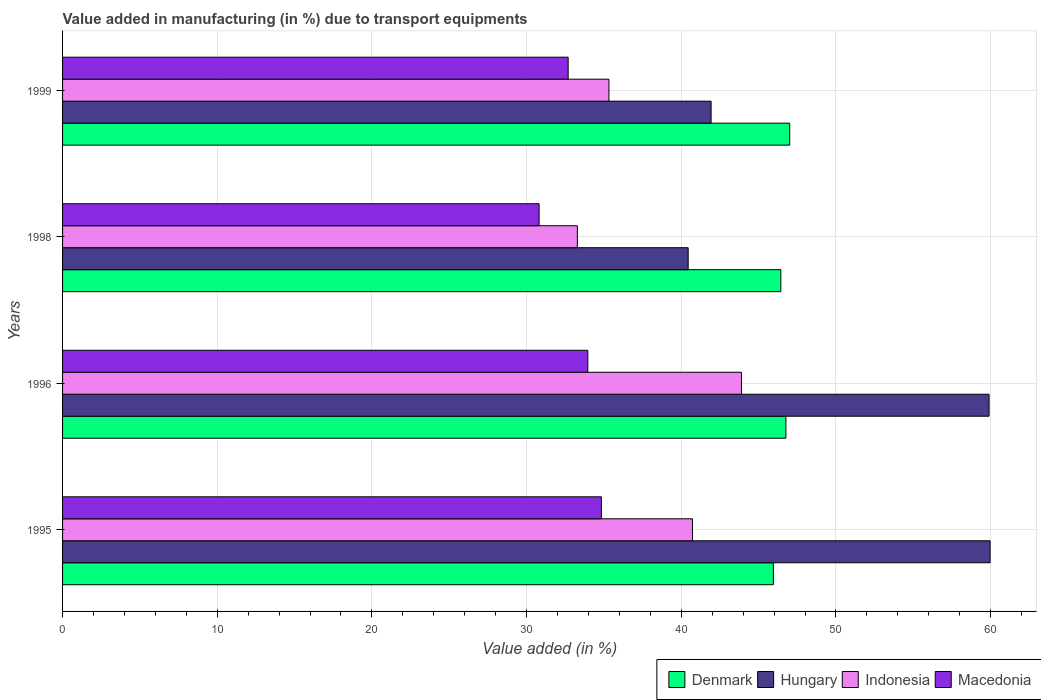Are the number of bars per tick equal to the number of legend labels?
Ensure brevity in your answer.  Yes. How many bars are there on the 1st tick from the top?
Give a very brief answer. 4. What is the label of the 2nd group of bars from the top?
Provide a short and direct response. 1998. What is the percentage of value added in manufacturing due to transport equipments in Macedonia in 1998?
Provide a short and direct response. 30.81. Across all years, what is the maximum percentage of value added in manufacturing due to transport equipments in Denmark?
Your answer should be very brief. 47.01. Across all years, what is the minimum percentage of value added in manufacturing due to transport equipments in Denmark?
Give a very brief answer. 45.95. In which year was the percentage of value added in manufacturing due to transport equipments in Indonesia maximum?
Your answer should be very brief. 1996. In which year was the percentage of value added in manufacturing due to transport equipments in Indonesia minimum?
Your answer should be compact. 1998. What is the total percentage of value added in manufacturing due to transport equipments in Indonesia in the graph?
Make the answer very short. 153.22. What is the difference between the percentage of value added in manufacturing due to transport equipments in Macedonia in 1995 and that in 1999?
Your answer should be compact. 2.15. What is the difference between the percentage of value added in manufacturing due to transport equipments in Indonesia in 1995 and the percentage of value added in manufacturing due to transport equipments in Hungary in 1998?
Your answer should be compact. 0.28. What is the average percentage of value added in manufacturing due to transport equipments in Indonesia per year?
Your response must be concise. 38.3. In the year 1995, what is the difference between the percentage of value added in manufacturing due to transport equipments in Denmark and percentage of value added in manufacturing due to transport equipments in Hungary?
Ensure brevity in your answer.  -14.01. In how many years, is the percentage of value added in manufacturing due to transport equipments in Hungary greater than 8 %?
Provide a short and direct response. 4. What is the ratio of the percentage of value added in manufacturing due to transport equipments in Denmark in 1998 to that in 1999?
Offer a terse response. 0.99. Is the percentage of value added in manufacturing due to transport equipments in Denmark in 1995 less than that in 1996?
Provide a short and direct response. Yes. Is the difference between the percentage of value added in manufacturing due to transport equipments in Denmark in 1996 and 1998 greater than the difference between the percentage of value added in manufacturing due to transport equipments in Hungary in 1996 and 1998?
Give a very brief answer. No. What is the difference between the highest and the second highest percentage of value added in manufacturing due to transport equipments in Denmark?
Your answer should be compact. 0.25. What is the difference between the highest and the lowest percentage of value added in manufacturing due to transport equipments in Denmark?
Your answer should be very brief. 1.06. Is it the case that in every year, the sum of the percentage of value added in manufacturing due to transport equipments in Indonesia and percentage of value added in manufacturing due to transport equipments in Hungary is greater than the sum of percentage of value added in manufacturing due to transport equipments in Denmark and percentage of value added in manufacturing due to transport equipments in Macedonia?
Keep it short and to the point. No. What does the 1st bar from the bottom in 1999 represents?
Provide a short and direct response. Denmark. How many bars are there?
Offer a terse response. 16. What is the difference between two consecutive major ticks on the X-axis?
Your answer should be very brief. 10. Are the values on the major ticks of X-axis written in scientific E-notation?
Your answer should be very brief. No. Does the graph contain any zero values?
Provide a short and direct response. No. Does the graph contain grids?
Offer a terse response. Yes. Where does the legend appear in the graph?
Keep it short and to the point. Bottom right. What is the title of the graph?
Make the answer very short. Value added in manufacturing (in %) due to transport equipments. Does "Tajikistan" appear as one of the legend labels in the graph?
Your answer should be very brief. No. What is the label or title of the X-axis?
Make the answer very short. Value added (in %). What is the Value added (in %) of Denmark in 1995?
Give a very brief answer. 45.95. What is the Value added (in %) of Hungary in 1995?
Keep it short and to the point. 59.97. What is the Value added (in %) in Indonesia in 1995?
Make the answer very short. 40.72. What is the Value added (in %) in Macedonia in 1995?
Offer a very short reply. 34.83. What is the Value added (in %) of Denmark in 1996?
Your answer should be very brief. 46.76. What is the Value added (in %) in Hungary in 1996?
Make the answer very short. 59.9. What is the Value added (in %) in Indonesia in 1996?
Offer a terse response. 43.89. What is the Value added (in %) of Macedonia in 1996?
Your answer should be very brief. 33.96. What is the Value added (in %) in Denmark in 1998?
Give a very brief answer. 46.44. What is the Value added (in %) of Hungary in 1998?
Your answer should be compact. 40.44. What is the Value added (in %) in Indonesia in 1998?
Make the answer very short. 33.28. What is the Value added (in %) of Macedonia in 1998?
Ensure brevity in your answer.  30.81. What is the Value added (in %) in Denmark in 1999?
Keep it short and to the point. 47.01. What is the Value added (in %) of Hungary in 1999?
Ensure brevity in your answer.  41.93. What is the Value added (in %) of Indonesia in 1999?
Your response must be concise. 35.32. What is the Value added (in %) of Macedonia in 1999?
Ensure brevity in your answer.  32.69. Across all years, what is the maximum Value added (in %) in Denmark?
Your answer should be very brief. 47.01. Across all years, what is the maximum Value added (in %) of Hungary?
Offer a very short reply. 59.97. Across all years, what is the maximum Value added (in %) of Indonesia?
Your response must be concise. 43.89. Across all years, what is the maximum Value added (in %) in Macedonia?
Give a very brief answer. 34.83. Across all years, what is the minimum Value added (in %) in Denmark?
Provide a succinct answer. 45.95. Across all years, what is the minimum Value added (in %) in Hungary?
Ensure brevity in your answer.  40.44. Across all years, what is the minimum Value added (in %) in Indonesia?
Ensure brevity in your answer.  33.28. Across all years, what is the minimum Value added (in %) of Macedonia?
Keep it short and to the point. 30.81. What is the total Value added (in %) of Denmark in the graph?
Your answer should be very brief. 186.16. What is the total Value added (in %) in Hungary in the graph?
Provide a succinct answer. 202.24. What is the total Value added (in %) of Indonesia in the graph?
Your response must be concise. 153.22. What is the total Value added (in %) of Macedonia in the graph?
Your answer should be very brief. 132.28. What is the difference between the Value added (in %) of Denmark in 1995 and that in 1996?
Give a very brief answer. -0.81. What is the difference between the Value added (in %) of Hungary in 1995 and that in 1996?
Keep it short and to the point. 0.07. What is the difference between the Value added (in %) of Indonesia in 1995 and that in 1996?
Ensure brevity in your answer.  -3.17. What is the difference between the Value added (in %) in Macedonia in 1995 and that in 1996?
Make the answer very short. 0.88. What is the difference between the Value added (in %) in Denmark in 1995 and that in 1998?
Your answer should be compact. -0.48. What is the difference between the Value added (in %) of Hungary in 1995 and that in 1998?
Make the answer very short. 19.52. What is the difference between the Value added (in %) in Indonesia in 1995 and that in 1998?
Provide a succinct answer. 7.44. What is the difference between the Value added (in %) of Macedonia in 1995 and that in 1998?
Offer a terse response. 4.03. What is the difference between the Value added (in %) of Denmark in 1995 and that in 1999?
Provide a short and direct response. -1.06. What is the difference between the Value added (in %) in Hungary in 1995 and that in 1999?
Provide a short and direct response. 18.04. What is the difference between the Value added (in %) of Indonesia in 1995 and that in 1999?
Offer a very short reply. 5.4. What is the difference between the Value added (in %) of Macedonia in 1995 and that in 1999?
Offer a very short reply. 2.15. What is the difference between the Value added (in %) in Denmark in 1996 and that in 1998?
Your response must be concise. 0.33. What is the difference between the Value added (in %) of Hungary in 1996 and that in 1998?
Give a very brief answer. 19.45. What is the difference between the Value added (in %) in Indonesia in 1996 and that in 1998?
Your answer should be very brief. 10.61. What is the difference between the Value added (in %) in Macedonia in 1996 and that in 1998?
Offer a terse response. 3.15. What is the difference between the Value added (in %) of Denmark in 1996 and that in 1999?
Your response must be concise. -0.25. What is the difference between the Value added (in %) of Hungary in 1996 and that in 1999?
Your response must be concise. 17.97. What is the difference between the Value added (in %) of Indonesia in 1996 and that in 1999?
Give a very brief answer. 8.57. What is the difference between the Value added (in %) of Macedonia in 1996 and that in 1999?
Keep it short and to the point. 1.27. What is the difference between the Value added (in %) in Denmark in 1998 and that in 1999?
Ensure brevity in your answer.  -0.57. What is the difference between the Value added (in %) in Hungary in 1998 and that in 1999?
Offer a very short reply. -1.48. What is the difference between the Value added (in %) of Indonesia in 1998 and that in 1999?
Provide a short and direct response. -2.04. What is the difference between the Value added (in %) of Macedonia in 1998 and that in 1999?
Provide a succinct answer. -1.88. What is the difference between the Value added (in %) in Denmark in 1995 and the Value added (in %) in Hungary in 1996?
Offer a very short reply. -13.94. What is the difference between the Value added (in %) of Denmark in 1995 and the Value added (in %) of Indonesia in 1996?
Your response must be concise. 2.06. What is the difference between the Value added (in %) of Denmark in 1995 and the Value added (in %) of Macedonia in 1996?
Offer a terse response. 12. What is the difference between the Value added (in %) of Hungary in 1995 and the Value added (in %) of Indonesia in 1996?
Make the answer very short. 16.07. What is the difference between the Value added (in %) in Hungary in 1995 and the Value added (in %) in Macedonia in 1996?
Offer a terse response. 26.01. What is the difference between the Value added (in %) of Indonesia in 1995 and the Value added (in %) of Macedonia in 1996?
Give a very brief answer. 6.77. What is the difference between the Value added (in %) in Denmark in 1995 and the Value added (in %) in Hungary in 1998?
Offer a very short reply. 5.51. What is the difference between the Value added (in %) in Denmark in 1995 and the Value added (in %) in Indonesia in 1998?
Offer a terse response. 12.67. What is the difference between the Value added (in %) of Denmark in 1995 and the Value added (in %) of Macedonia in 1998?
Make the answer very short. 15.14. What is the difference between the Value added (in %) of Hungary in 1995 and the Value added (in %) of Indonesia in 1998?
Offer a terse response. 26.68. What is the difference between the Value added (in %) of Hungary in 1995 and the Value added (in %) of Macedonia in 1998?
Offer a very short reply. 29.16. What is the difference between the Value added (in %) in Indonesia in 1995 and the Value added (in %) in Macedonia in 1998?
Your answer should be compact. 9.92. What is the difference between the Value added (in %) in Denmark in 1995 and the Value added (in %) in Hungary in 1999?
Provide a short and direct response. 4.02. What is the difference between the Value added (in %) of Denmark in 1995 and the Value added (in %) of Indonesia in 1999?
Your answer should be very brief. 10.63. What is the difference between the Value added (in %) in Denmark in 1995 and the Value added (in %) in Macedonia in 1999?
Ensure brevity in your answer.  13.27. What is the difference between the Value added (in %) of Hungary in 1995 and the Value added (in %) of Indonesia in 1999?
Offer a very short reply. 24.64. What is the difference between the Value added (in %) in Hungary in 1995 and the Value added (in %) in Macedonia in 1999?
Offer a very short reply. 27.28. What is the difference between the Value added (in %) of Indonesia in 1995 and the Value added (in %) of Macedonia in 1999?
Offer a very short reply. 8.04. What is the difference between the Value added (in %) of Denmark in 1996 and the Value added (in %) of Hungary in 1998?
Ensure brevity in your answer.  6.32. What is the difference between the Value added (in %) in Denmark in 1996 and the Value added (in %) in Indonesia in 1998?
Your answer should be compact. 13.48. What is the difference between the Value added (in %) in Denmark in 1996 and the Value added (in %) in Macedonia in 1998?
Ensure brevity in your answer.  15.96. What is the difference between the Value added (in %) of Hungary in 1996 and the Value added (in %) of Indonesia in 1998?
Your answer should be compact. 26.62. What is the difference between the Value added (in %) of Hungary in 1996 and the Value added (in %) of Macedonia in 1998?
Your answer should be compact. 29.09. What is the difference between the Value added (in %) in Indonesia in 1996 and the Value added (in %) in Macedonia in 1998?
Provide a short and direct response. 13.08. What is the difference between the Value added (in %) of Denmark in 1996 and the Value added (in %) of Hungary in 1999?
Make the answer very short. 4.84. What is the difference between the Value added (in %) in Denmark in 1996 and the Value added (in %) in Indonesia in 1999?
Ensure brevity in your answer.  11.44. What is the difference between the Value added (in %) of Denmark in 1996 and the Value added (in %) of Macedonia in 1999?
Give a very brief answer. 14.08. What is the difference between the Value added (in %) of Hungary in 1996 and the Value added (in %) of Indonesia in 1999?
Offer a terse response. 24.58. What is the difference between the Value added (in %) in Hungary in 1996 and the Value added (in %) in Macedonia in 1999?
Make the answer very short. 27.21. What is the difference between the Value added (in %) in Indonesia in 1996 and the Value added (in %) in Macedonia in 1999?
Keep it short and to the point. 11.21. What is the difference between the Value added (in %) of Denmark in 1998 and the Value added (in %) of Hungary in 1999?
Offer a very short reply. 4.51. What is the difference between the Value added (in %) of Denmark in 1998 and the Value added (in %) of Indonesia in 1999?
Your answer should be compact. 11.11. What is the difference between the Value added (in %) of Denmark in 1998 and the Value added (in %) of Macedonia in 1999?
Offer a terse response. 13.75. What is the difference between the Value added (in %) in Hungary in 1998 and the Value added (in %) in Indonesia in 1999?
Give a very brief answer. 5.12. What is the difference between the Value added (in %) in Hungary in 1998 and the Value added (in %) in Macedonia in 1999?
Your response must be concise. 7.76. What is the difference between the Value added (in %) of Indonesia in 1998 and the Value added (in %) of Macedonia in 1999?
Offer a very short reply. 0.59. What is the average Value added (in %) of Denmark per year?
Your answer should be compact. 46.54. What is the average Value added (in %) in Hungary per year?
Provide a short and direct response. 50.56. What is the average Value added (in %) of Indonesia per year?
Offer a terse response. 38.3. What is the average Value added (in %) in Macedonia per year?
Keep it short and to the point. 33.07. In the year 1995, what is the difference between the Value added (in %) in Denmark and Value added (in %) in Hungary?
Keep it short and to the point. -14.01. In the year 1995, what is the difference between the Value added (in %) in Denmark and Value added (in %) in Indonesia?
Make the answer very short. 5.23. In the year 1995, what is the difference between the Value added (in %) in Denmark and Value added (in %) in Macedonia?
Make the answer very short. 11.12. In the year 1995, what is the difference between the Value added (in %) in Hungary and Value added (in %) in Indonesia?
Your answer should be very brief. 19.24. In the year 1995, what is the difference between the Value added (in %) of Hungary and Value added (in %) of Macedonia?
Your answer should be very brief. 25.13. In the year 1995, what is the difference between the Value added (in %) of Indonesia and Value added (in %) of Macedonia?
Keep it short and to the point. 5.89. In the year 1996, what is the difference between the Value added (in %) of Denmark and Value added (in %) of Hungary?
Ensure brevity in your answer.  -13.13. In the year 1996, what is the difference between the Value added (in %) in Denmark and Value added (in %) in Indonesia?
Offer a terse response. 2.87. In the year 1996, what is the difference between the Value added (in %) of Denmark and Value added (in %) of Macedonia?
Provide a succinct answer. 12.81. In the year 1996, what is the difference between the Value added (in %) in Hungary and Value added (in %) in Indonesia?
Your answer should be compact. 16.01. In the year 1996, what is the difference between the Value added (in %) in Hungary and Value added (in %) in Macedonia?
Make the answer very short. 25.94. In the year 1996, what is the difference between the Value added (in %) in Indonesia and Value added (in %) in Macedonia?
Offer a very short reply. 9.93. In the year 1998, what is the difference between the Value added (in %) in Denmark and Value added (in %) in Hungary?
Make the answer very short. 5.99. In the year 1998, what is the difference between the Value added (in %) of Denmark and Value added (in %) of Indonesia?
Your response must be concise. 13.15. In the year 1998, what is the difference between the Value added (in %) of Denmark and Value added (in %) of Macedonia?
Give a very brief answer. 15.63. In the year 1998, what is the difference between the Value added (in %) of Hungary and Value added (in %) of Indonesia?
Your answer should be compact. 7.16. In the year 1998, what is the difference between the Value added (in %) of Hungary and Value added (in %) of Macedonia?
Provide a succinct answer. 9.64. In the year 1998, what is the difference between the Value added (in %) of Indonesia and Value added (in %) of Macedonia?
Ensure brevity in your answer.  2.47. In the year 1999, what is the difference between the Value added (in %) of Denmark and Value added (in %) of Hungary?
Ensure brevity in your answer.  5.08. In the year 1999, what is the difference between the Value added (in %) of Denmark and Value added (in %) of Indonesia?
Provide a succinct answer. 11.69. In the year 1999, what is the difference between the Value added (in %) in Denmark and Value added (in %) in Macedonia?
Your answer should be compact. 14.32. In the year 1999, what is the difference between the Value added (in %) of Hungary and Value added (in %) of Indonesia?
Your response must be concise. 6.61. In the year 1999, what is the difference between the Value added (in %) in Hungary and Value added (in %) in Macedonia?
Offer a very short reply. 9.24. In the year 1999, what is the difference between the Value added (in %) of Indonesia and Value added (in %) of Macedonia?
Your answer should be compact. 2.64. What is the ratio of the Value added (in %) of Denmark in 1995 to that in 1996?
Give a very brief answer. 0.98. What is the ratio of the Value added (in %) in Hungary in 1995 to that in 1996?
Your answer should be very brief. 1. What is the ratio of the Value added (in %) of Indonesia in 1995 to that in 1996?
Keep it short and to the point. 0.93. What is the ratio of the Value added (in %) of Macedonia in 1995 to that in 1996?
Keep it short and to the point. 1.03. What is the ratio of the Value added (in %) in Denmark in 1995 to that in 1998?
Give a very brief answer. 0.99. What is the ratio of the Value added (in %) of Hungary in 1995 to that in 1998?
Keep it short and to the point. 1.48. What is the ratio of the Value added (in %) in Indonesia in 1995 to that in 1998?
Provide a succinct answer. 1.22. What is the ratio of the Value added (in %) of Macedonia in 1995 to that in 1998?
Provide a succinct answer. 1.13. What is the ratio of the Value added (in %) of Denmark in 1995 to that in 1999?
Ensure brevity in your answer.  0.98. What is the ratio of the Value added (in %) in Hungary in 1995 to that in 1999?
Give a very brief answer. 1.43. What is the ratio of the Value added (in %) of Indonesia in 1995 to that in 1999?
Offer a terse response. 1.15. What is the ratio of the Value added (in %) of Macedonia in 1995 to that in 1999?
Offer a very short reply. 1.07. What is the ratio of the Value added (in %) of Denmark in 1996 to that in 1998?
Make the answer very short. 1.01. What is the ratio of the Value added (in %) in Hungary in 1996 to that in 1998?
Make the answer very short. 1.48. What is the ratio of the Value added (in %) of Indonesia in 1996 to that in 1998?
Your answer should be very brief. 1.32. What is the ratio of the Value added (in %) of Macedonia in 1996 to that in 1998?
Offer a terse response. 1.1. What is the ratio of the Value added (in %) of Hungary in 1996 to that in 1999?
Offer a terse response. 1.43. What is the ratio of the Value added (in %) in Indonesia in 1996 to that in 1999?
Provide a succinct answer. 1.24. What is the ratio of the Value added (in %) of Macedonia in 1996 to that in 1999?
Provide a succinct answer. 1.04. What is the ratio of the Value added (in %) in Denmark in 1998 to that in 1999?
Offer a terse response. 0.99. What is the ratio of the Value added (in %) in Hungary in 1998 to that in 1999?
Your answer should be compact. 0.96. What is the ratio of the Value added (in %) of Indonesia in 1998 to that in 1999?
Provide a short and direct response. 0.94. What is the ratio of the Value added (in %) in Macedonia in 1998 to that in 1999?
Provide a succinct answer. 0.94. What is the difference between the highest and the second highest Value added (in %) in Denmark?
Keep it short and to the point. 0.25. What is the difference between the highest and the second highest Value added (in %) in Hungary?
Your answer should be compact. 0.07. What is the difference between the highest and the second highest Value added (in %) in Indonesia?
Make the answer very short. 3.17. What is the difference between the highest and the second highest Value added (in %) of Macedonia?
Offer a terse response. 0.88. What is the difference between the highest and the lowest Value added (in %) of Denmark?
Give a very brief answer. 1.06. What is the difference between the highest and the lowest Value added (in %) of Hungary?
Give a very brief answer. 19.52. What is the difference between the highest and the lowest Value added (in %) of Indonesia?
Provide a succinct answer. 10.61. What is the difference between the highest and the lowest Value added (in %) in Macedonia?
Provide a succinct answer. 4.03. 